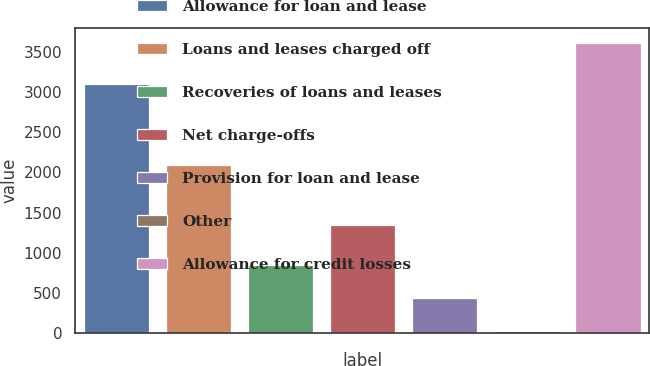Convert chart to OTSL. <chart><loc_0><loc_0><loc_500><loc_500><bar_chart><fcel>Allowance for loan and lease<fcel>Loans and leases charged off<fcel>Recoveries of loans and leases<fcel>Net charge-offs<fcel>Provision for loan and lease<fcel>Other<fcel>Allowance for credit losses<nl><fcel>3106<fcel>2096<fcel>843<fcel>1347<fcel>431.5<fcel>20<fcel>3619<nl></chart> 